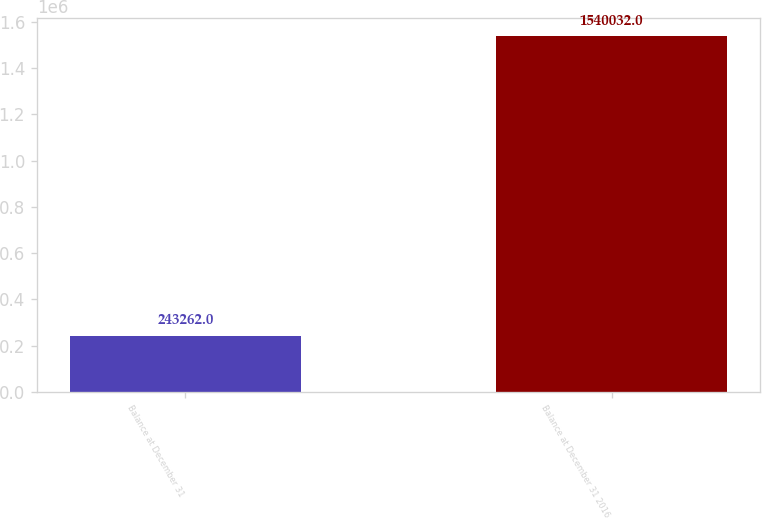<chart> <loc_0><loc_0><loc_500><loc_500><bar_chart><fcel>Balance at December 31<fcel>Balance at December 31 2016<nl><fcel>243262<fcel>1.54003e+06<nl></chart> 